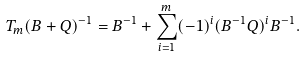<formula> <loc_0><loc_0><loc_500><loc_500>T _ { m } ( B + Q ) ^ { - 1 } = B ^ { - 1 } + \sum _ { i = 1 } ^ { m } ( - 1 ) ^ { i } ( B ^ { - 1 } Q ) ^ { i } B ^ { - 1 } .</formula> 